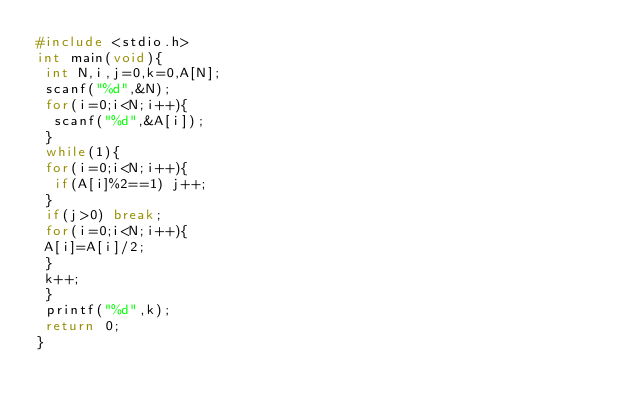<code> <loc_0><loc_0><loc_500><loc_500><_C_>#include <stdio.h>
int main(void){
 int N,i,j=0,k=0,A[N];
 scanf("%d",&N);
 for(i=0;i<N;i++){
  scanf("%d",&A[i]);
 }
 while(1){
 for(i=0;i<N;i++){
  if(A[i]%2==1) j++;
 }
 if(j>0) break;
 for(i=0;i<N;i++){
 A[i]=A[i]/2;
 }
 k++;
 }
 printf("%d",k);
 return 0;
}</code> 